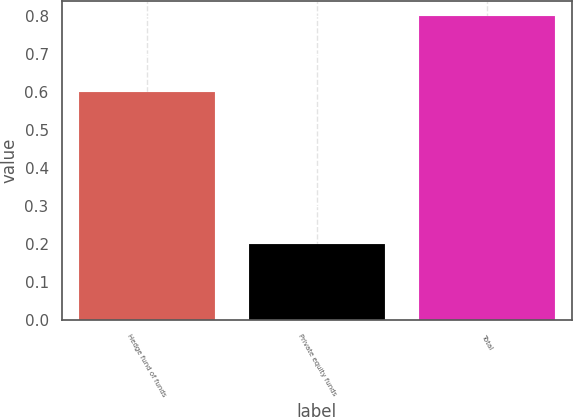Convert chart to OTSL. <chart><loc_0><loc_0><loc_500><loc_500><bar_chart><fcel>Hedge fund of funds<fcel>Private equity funds<fcel>Total<nl><fcel>0.6<fcel>0.2<fcel>0.8<nl></chart> 